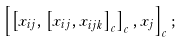Convert formula to latex. <formula><loc_0><loc_0><loc_500><loc_500>\left [ \left [ x _ { i j } , \left [ x _ { i j } , x _ { i j k } \right ] _ { c } \right ] _ { c } , x _ { j } \right ] _ { c } ;</formula> 